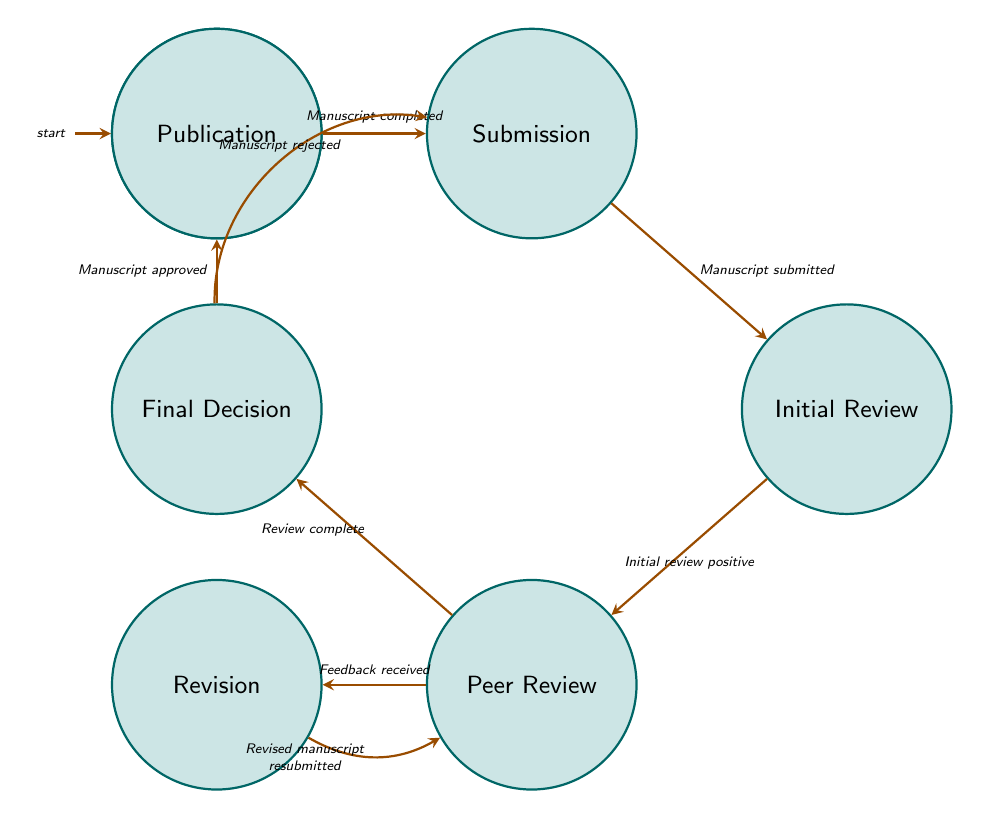What is the final state in this diagram? The final state is "Publication", which is the last node in the flow indicating where the approved manuscript is published in the journal.
Answer: Publication How many states are present in the diagram? There are seven states: Formulation, Submission, Initial Review, Peer Review, Revision, Final Decision, and Publication. Counting each listed state results in a total of seven.
Answer: Seven What action is taken in the "Submission" state? In the "Submission" state, authors "Prepare manuscript", "Select journal", and "Submit document", which are listed as actions that occur during this state.
Answer: Prepare manuscript, Select journal, Submit document What is the trigger to move from "Revision" back to "Peer Review"? The trigger to return to "Peer Review" from "Revision" is "Revised manuscript resubmitted", indicating that authors resubmit their work following revisions based on feedback received during the peer review.
Answer: Revised manuscript resubmitted What condition leads to a rejection of the manuscript in the "Final Decision" state? The condition for rejection in the "Final Decision" state is "Rejected", which determines the flow back to the "Submission" state if the manuscript does not meet the journal’s criteria for approval.
Answer: Rejected What are the actions performed in the "Peer Review" state? In the "Peer Review" state, the actions include "Review theoretical soundness", "Evaluate methodology", and "Provide feedback", which describe the detailed analysis conducted by reviewers on the manuscript.
Answer: Review theoretical soundness, Evaluate methodology, Provide feedback How many transitions are there in the diagram? There are eight transitions in total, which connect the various states based on triggers and conditions outlined in the diagram.
Answer: Eight 